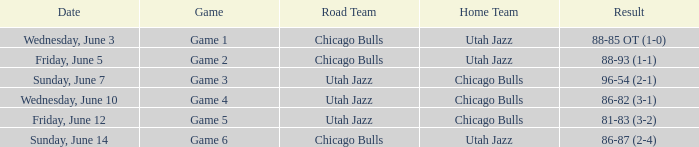Result of 88-85 ot (1-0) involves what game? Game 1. 